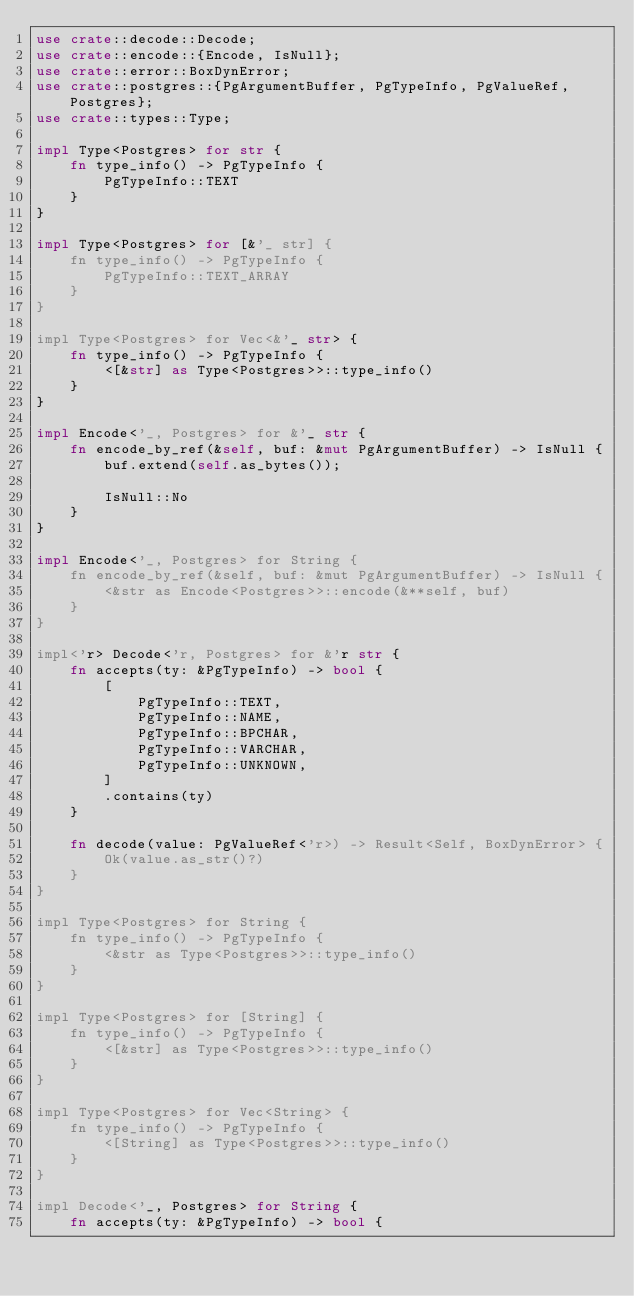Convert code to text. <code><loc_0><loc_0><loc_500><loc_500><_Rust_>use crate::decode::Decode;
use crate::encode::{Encode, IsNull};
use crate::error::BoxDynError;
use crate::postgres::{PgArgumentBuffer, PgTypeInfo, PgValueRef, Postgres};
use crate::types::Type;

impl Type<Postgres> for str {
    fn type_info() -> PgTypeInfo {
        PgTypeInfo::TEXT
    }
}

impl Type<Postgres> for [&'_ str] {
    fn type_info() -> PgTypeInfo {
        PgTypeInfo::TEXT_ARRAY
    }
}

impl Type<Postgres> for Vec<&'_ str> {
    fn type_info() -> PgTypeInfo {
        <[&str] as Type<Postgres>>::type_info()
    }
}

impl Encode<'_, Postgres> for &'_ str {
    fn encode_by_ref(&self, buf: &mut PgArgumentBuffer) -> IsNull {
        buf.extend(self.as_bytes());

        IsNull::No
    }
}

impl Encode<'_, Postgres> for String {
    fn encode_by_ref(&self, buf: &mut PgArgumentBuffer) -> IsNull {
        <&str as Encode<Postgres>>::encode(&**self, buf)
    }
}

impl<'r> Decode<'r, Postgres> for &'r str {
    fn accepts(ty: &PgTypeInfo) -> bool {
        [
            PgTypeInfo::TEXT,
            PgTypeInfo::NAME,
            PgTypeInfo::BPCHAR,
            PgTypeInfo::VARCHAR,
            PgTypeInfo::UNKNOWN,
        ]
        .contains(ty)
    }

    fn decode(value: PgValueRef<'r>) -> Result<Self, BoxDynError> {
        Ok(value.as_str()?)
    }
}

impl Type<Postgres> for String {
    fn type_info() -> PgTypeInfo {
        <&str as Type<Postgres>>::type_info()
    }
}

impl Type<Postgres> for [String] {
    fn type_info() -> PgTypeInfo {
        <[&str] as Type<Postgres>>::type_info()
    }
}

impl Type<Postgres> for Vec<String> {
    fn type_info() -> PgTypeInfo {
        <[String] as Type<Postgres>>::type_info()
    }
}

impl Decode<'_, Postgres> for String {
    fn accepts(ty: &PgTypeInfo) -> bool {</code> 